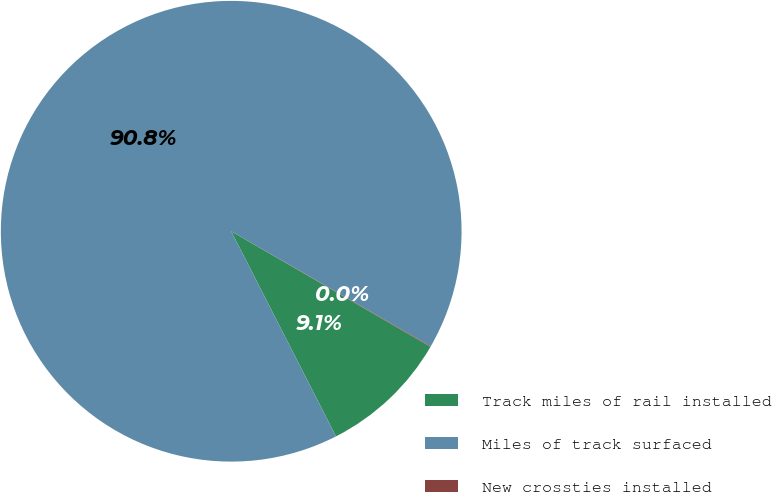Convert chart to OTSL. <chart><loc_0><loc_0><loc_500><loc_500><pie_chart><fcel>Track miles of rail installed<fcel>Miles of track surfaced<fcel>New crossties installed<nl><fcel>9.12%<fcel>90.84%<fcel>0.04%<nl></chart> 